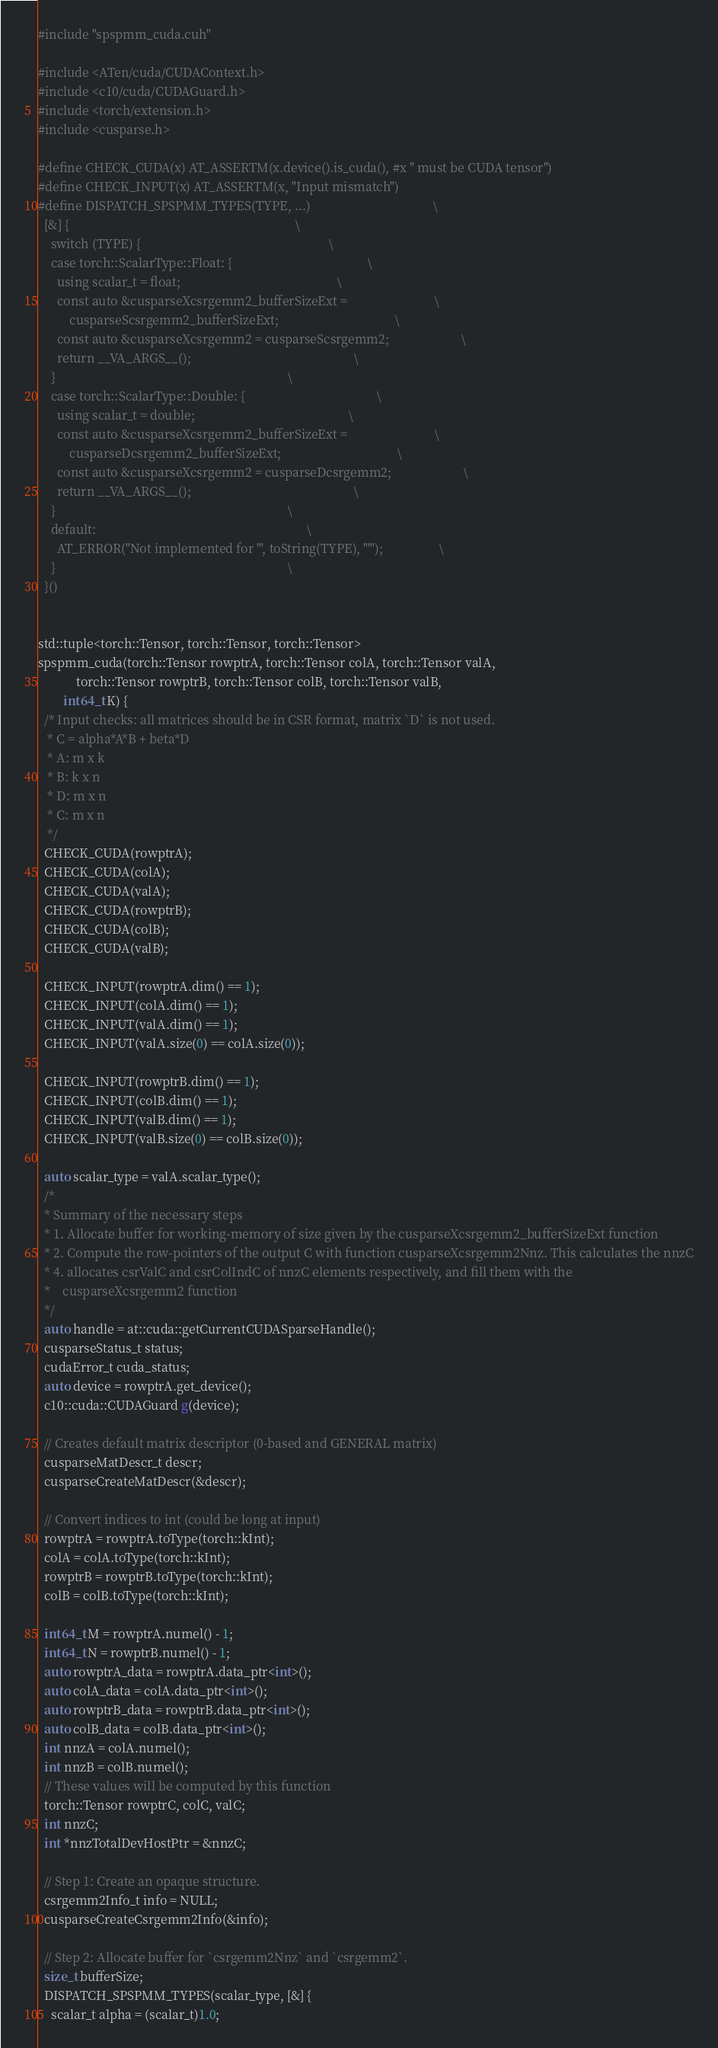<code> <loc_0><loc_0><loc_500><loc_500><_Cuda_>#include "spspmm_cuda.cuh"

#include <ATen/cuda/CUDAContext.h>
#include <c10/cuda/CUDAGuard.h>
#include <torch/extension.h>
#include <cusparse.h>

#define CHECK_CUDA(x) AT_ASSERTM(x.device().is_cuda(), #x " must be CUDA tensor")
#define CHECK_INPUT(x) AT_ASSERTM(x, "Input mismatch")
#define DISPATCH_SPSPMM_TYPES(TYPE, ...)                                       \
  [&] {                                                                        \
    switch (TYPE) {                                                            \
    case torch::ScalarType::Float: {                                           \
      using scalar_t = float;                                                  \
      const auto &cusparseXcsrgemm2_bufferSizeExt =                            \
          cusparseScsrgemm2_bufferSizeExt;                                     \
      const auto &cusparseXcsrgemm2 = cusparseScsrgemm2;                       \
      return __VA_ARGS__();                                                    \
    }                                                                          \
    case torch::ScalarType::Double: {                                          \
      using scalar_t = double;                                                 \
      const auto &cusparseXcsrgemm2_bufferSizeExt =                            \
          cusparseDcsrgemm2_bufferSizeExt;                                     \
      const auto &cusparseXcsrgemm2 = cusparseDcsrgemm2;                       \
      return __VA_ARGS__();                                                    \
    }                                                                          \
    default:                                                                   \
      AT_ERROR("Not implemented for '", toString(TYPE), "'");                  \
    }                                                                          \
  }()


std::tuple<torch::Tensor, torch::Tensor, torch::Tensor>
spspmm_cuda(torch::Tensor rowptrA, torch::Tensor colA, torch::Tensor valA,
            torch::Tensor rowptrB, torch::Tensor colB, torch::Tensor valB, 
	    int64_t K) {
  /* Input checks: all matrices should be in CSR format, matrix `D` is not used.
   * C = alpha*A*B + beta*D
   * A: m x k
   * B: k x n
   * D: m x n
   * C: m x n
   */
  CHECK_CUDA(rowptrA);
  CHECK_CUDA(colA);
  CHECK_CUDA(valA);
  CHECK_CUDA(rowptrB);
  CHECK_CUDA(colB);
  CHECK_CUDA(valB);

  CHECK_INPUT(rowptrA.dim() == 1);
  CHECK_INPUT(colA.dim() == 1);
  CHECK_INPUT(valA.dim() == 1);
  CHECK_INPUT(valA.size(0) == colA.size(0));

  CHECK_INPUT(rowptrB.dim() == 1);
  CHECK_INPUT(colB.dim() == 1);
  CHECK_INPUT(valB.dim() == 1);
  CHECK_INPUT(valB.size(0) == colB.size(0));

  auto scalar_type = valA.scalar_type();
  /*
  * Summary of the necessary steps
  * 1. Allocate buffer for working-memory of size given by the cusparseXcsrgemm2_bufferSizeExt function
  * 2. Compute the row-pointers of the output C with function cusparseXcsrgemm2Nnz. This calculates the nnzC
  * 4. allocates csrValC and csrColIndC of nnzC elements respectively, and fill them with the
  *    cusparseXcsrgemm2 function
  */
  auto handle = at::cuda::getCurrentCUDASparseHandle();
  cusparseStatus_t status;
  cudaError_t cuda_status;
  auto device = rowptrA.get_device();
  c10::cuda::CUDAGuard g(device);

  // Creates default matrix descriptor (0-based and GENERAL matrix)
  cusparseMatDescr_t descr;
  cusparseCreateMatDescr(&descr);

  // Convert indices to int (could be long at input)
  rowptrA = rowptrA.toType(torch::kInt);
  colA = colA.toType(torch::kInt);
  rowptrB = rowptrB.toType(torch::kInt);
  colB = colB.toType(torch::kInt);

  int64_t M = rowptrA.numel() - 1;
  int64_t N = rowptrB.numel() - 1;
  auto rowptrA_data = rowptrA.data_ptr<int>();
  auto colA_data = colA.data_ptr<int>();
  auto rowptrB_data = rowptrB.data_ptr<int>();
  auto colB_data = colB.data_ptr<int>();
  int nnzA = colA.numel();
  int nnzB = colB.numel();
  // These values will be computed by this function
  torch::Tensor rowptrC, colC, valC;
  int nnzC;
  int *nnzTotalDevHostPtr = &nnzC;

  // Step 1: Create an opaque structure.
  csrgemm2Info_t info = NULL;
  cusparseCreateCsrgemm2Info(&info);

  // Step 2: Allocate buffer for `csrgemm2Nnz` and `csrgemm2`.
  size_t bufferSize;
  DISPATCH_SPSPMM_TYPES(scalar_type, [&] {
    scalar_t alpha = (scalar_t)1.0;</code> 